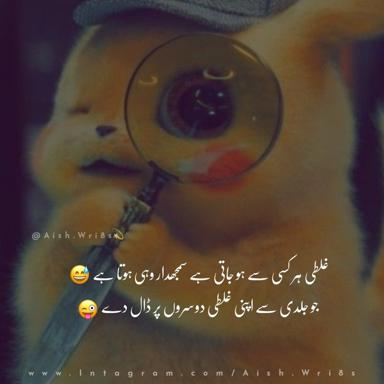Can you describe the hat in the image? The hat in the image is whimsically designed, featuring the beloved Pokemon character, Pikachu. It is not just a simple accessory; it includes a built-in magnifying glass, which is both a practical and playful addition. The hat appears to be made of a soft fabric, possibly felt, in yellow, emphasizing Pikachu's iconic color. Such a creative and functional hat might appeal to both fans of Pokemon and those who appreciate unique fashion accessories. 